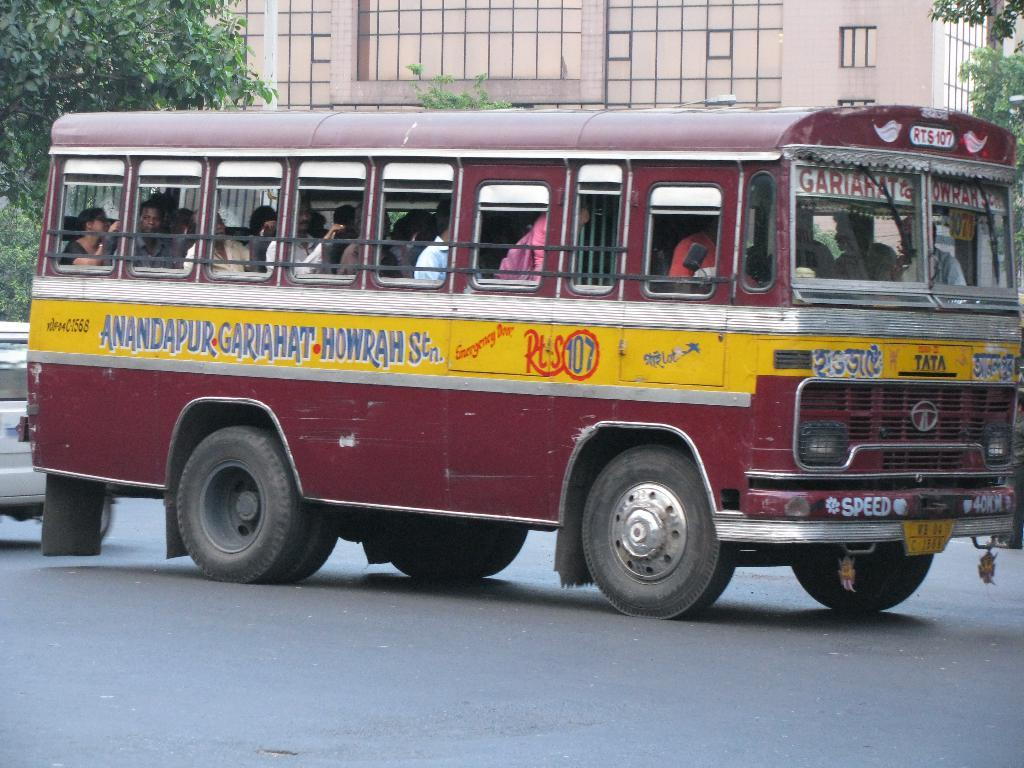<image>
Share a concise interpretation of the image provided. A tour bus that says Speed on the front of it. 